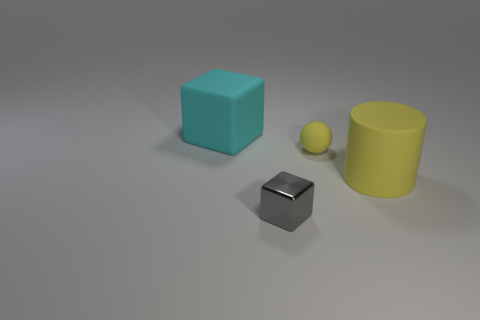Add 1 matte things. How many objects exist? 5 Subtract all spheres. How many objects are left? 3 Subtract all matte things. Subtract all tiny red matte balls. How many objects are left? 1 Add 4 tiny gray metal things. How many tiny gray metal things are left? 5 Add 2 tiny metallic objects. How many tiny metallic objects exist? 3 Subtract 0 yellow blocks. How many objects are left? 4 